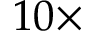Convert formula to latex. <formula><loc_0><loc_0><loc_500><loc_500>1 0 \times</formula> 